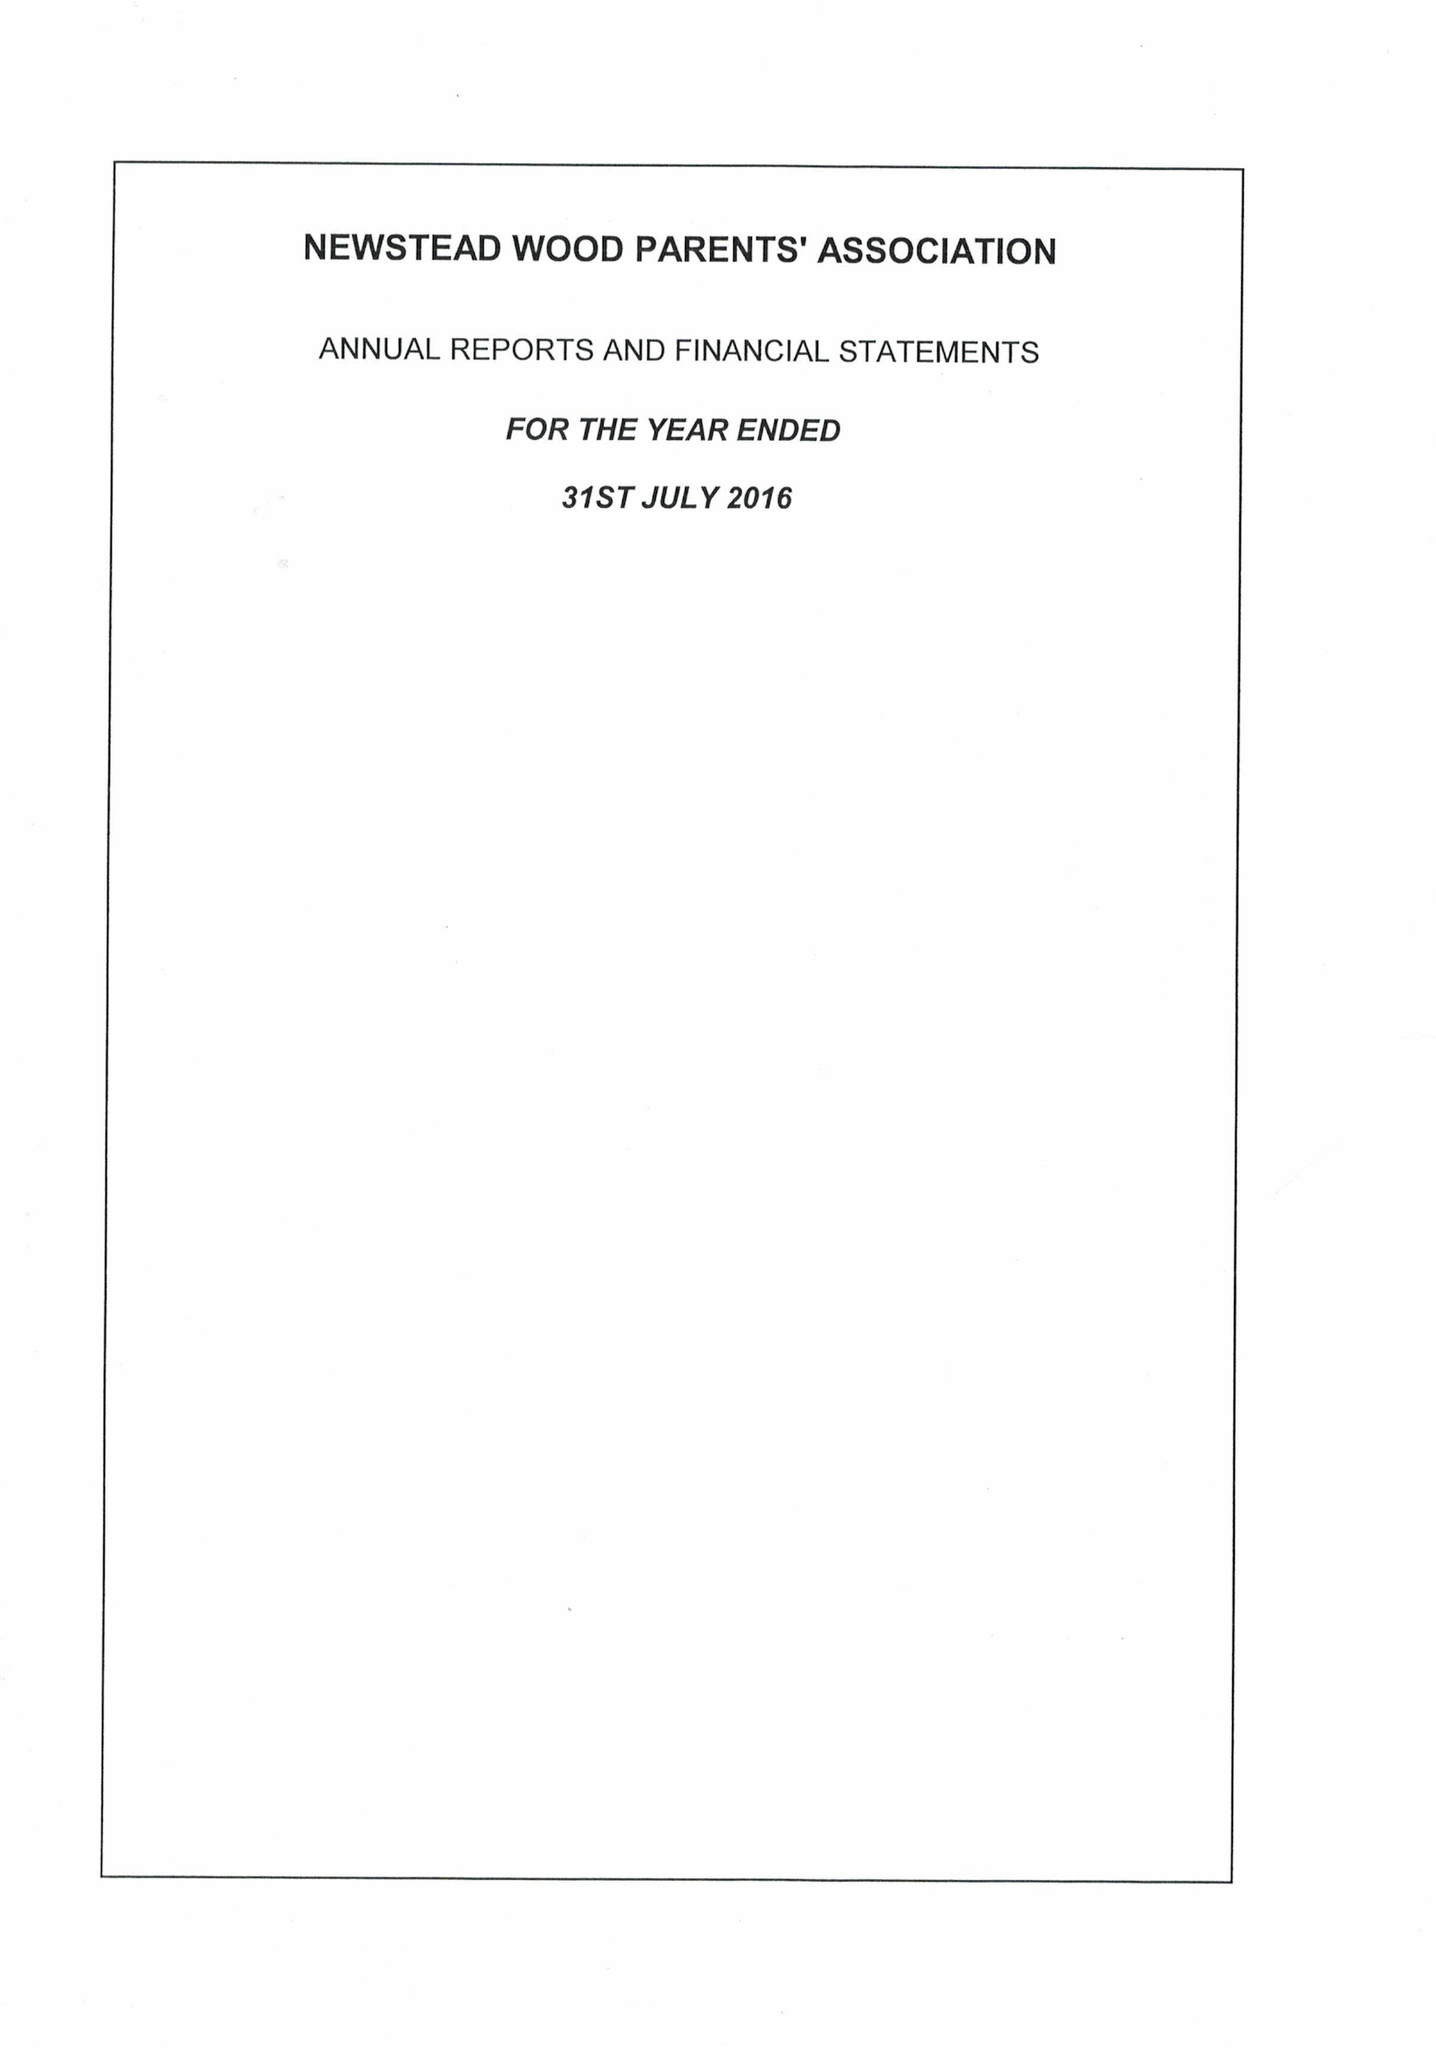What is the value for the income_annually_in_british_pounds?
Answer the question using a single word or phrase. 47620.00 